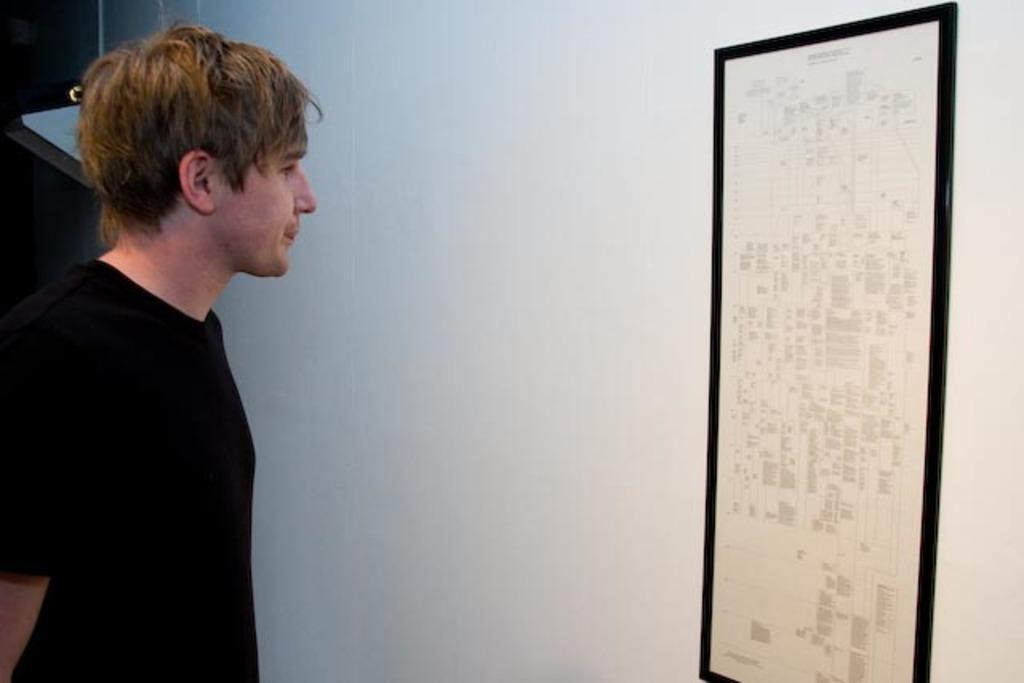Describe this image in one or two sentences. On the left of this picture we can see a person wearing black color t-shirt and standing. On the right we can see a poster containing the text and the drawing which is attached to the wall. In the background we can see some objects. 